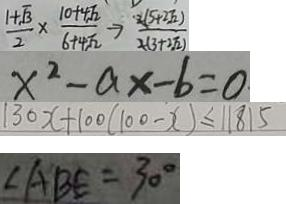Convert formula to latex. <formula><loc_0><loc_0><loc_500><loc_500>\frac { 1 + \sqrt { 3 } } { 2 } \times \frac { 1 0 + 4 \sqrt { 2 } } { 6 + 4 \sqrt { 2 } } \rightarrow \frac { 2 ( 5 + 2 \sqrt { 2 } ) } { 2 ( 3 + 2 \sqrt { 2 } ) } 
 x ^ { 2 } - a x - b = 0 
 1 3 0 x + 1 0 0 ( 1 0 0 - x ) \leq 1 1 8 1 5 
 \angle A B E = 3 0 ^ { \circ }</formula> 